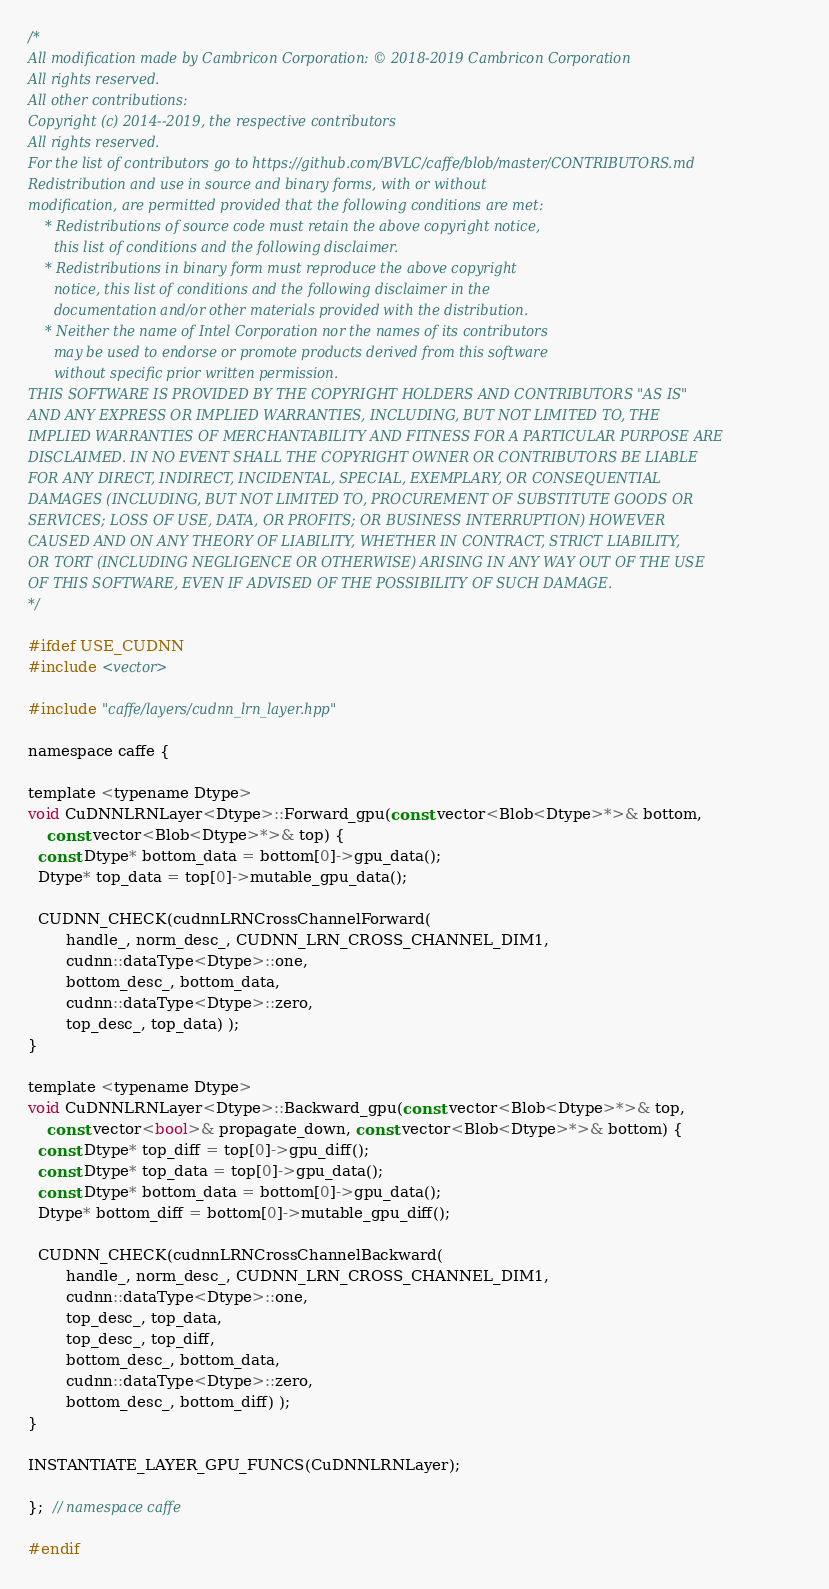Convert code to text. <code><loc_0><loc_0><loc_500><loc_500><_Cuda_>/*
All modification made by Cambricon Corporation: © 2018-2019 Cambricon Corporation
All rights reserved.
All other contributions:
Copyright (c) 2014--2019, the respective contributors
All rights reserved.
For the list of contributors go to https://github.com/BVLC/caffe/blob/master/CONTRIBUTORS.md
Redistribution and use in source and binary forms, with or without
modification, are permitted provided that the following conditions are met:
    * Redistributions of source code must retain the above copyright notice,
      this list of conditions and the following disclaimer.
    * Redistributions in binary form must reproduce the above copyright
      notice, this list of conditions and the following disclaimer in the
      documentation and/or other materials provided with the distribution.
    * Neither the name of Intel Corporation nor the names of its contributors
      may be used to endorse or promote products derived from this software
      without specific prior written permission.
THIS SOFTWARE IS PROVIDED BY THE COPYRIGHT HOLDERS AND CONTRIBUTORS "AS IS"
AND ANY EXPRESS OR IMPLIED WARRANTIES, INCLUDING, BUT NOT LIMITED TO, THE
IMPLIED WARRANTIES OF MERCHANTABILITY AND FITNESS FOR A PARTICULAR PURPOSE ARE
DISCLAIMED. IN NO EVENT SHALL THE COPYRIGHT OWNER OR CONTRIBUTORS BE LIABLE
FOR ANY DIRECT, INDIRECT, INCIDENTAL, SPECIAL, EXEMPLARY, OR CONSEQUENTIAL
DAMAGES (INCLUDING, BUT NOT LIMITED TO, PROCUREMENT OF SUBSTITUTE GOODS OR
SERVICES; LOSS OF USE, DATA, OR PROFITS; OR BUSINESS INTERRUPTION) HOWEVER
CAUSED AND ON ANY THEORY OF LIABILITY, WHETHER IN CONTRACT, STRICT LIABILITY,
OR TORT (INCLUDING NEGLIGENCE OR OTHERWISE) ARISING IN ANY WAY OUT OF THE USE
OF THIS SOFTWARE, EVEN IF ADVISED OF THE POSSIBILITY OF SUCH DAMAGE.
*/

#ifdef USE_CUDNN
#include <vector>

#include "caffe/layers/cudnn_lrn_layer.hpp"

namespace caffe {

template <typename Dtype>
void CuDNNLRNLayer<Dtype>::Forward_gpu(const vector<Blob<Dtype>*>& bottom,
    const vector<Blob<Dtype>*>& top) {
  const Dtype* bottom_data = bottom[0]->gpu_data();
  Dtype* top_data = top[0]->mutable_gpu_data();

  CUDNN_CHECK(cudnnLRNCrossChannelForward(
        handle_, norm_desc_, CUDNN_LRN_CROSS_CHANNEL_DIM1,
        cudnn::dataType<Dtype>::one,
        bottom_desc_, bottom_data,
        cudnn::dataType<Dtype>::zero,
        top_desc_, top_data) );
}

template <typename Dtype>
void CuDNNLRNLayer<Dtype>::Backward_gpu(const vector<Blob<Dtype>*>& top,
    const vector<bool>& propagate_down, const vector<Blob<Dtype>*>& bottom) {
  const Dtype* top_diff = top[0]->gpu_diff();
  const Dtype* top_data = top[0]->gpu_data();
  const Dtype* bottom_data = bottom[0]->gpu_data();
  Dtype* bottom_diff = bottom[0]->mutable_gpu_diff();

  CUDNN_CHECK(cudnnLRNCrossChannelBackward(
        handle_, norm_desc_, CUDNN_LRN_CROSS_CHANNEL_DIM1,
        cudnn::dataType<Dtype>::one,
        top_desc_, top_data,
        top_desc_, top_diff,
        bottom_desc_, bottom_data,
        cudnn::dataType<Dtype>::zero,
        bottom_desc_, bottom_diff) );
}

INSTANTIATE_LAYER_GPU_FUNCS(CuDNNLRNLayer);

};  // namespace caffe

#endif
</code> 